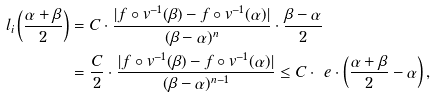<formula> <loc_0><loc_0><loc_500><loc_500>l _ { i } \left ( \frac { \alpha + \beta } { 2 } \right ) & = C \cdot \frac { | f \circ v ^ { - 1 } ( \beta ) - f \circ v ^ { - 1 } ( \alpha ) | } { ( \beta - \alpha ) ^ { n } } \cdot \frac { \beta - \alpha } { 2 } \\ & = \frac { C } { 2 } \cdot \frac { | f \circ v ^ { - 1 } ( \beta ) - f \circ v ^ { - 1 } ( \alpha ) | } { ( \beta - \alpha ) ^ { n - 1 } } \leq C \cdot \ e \cdot \left ( \frac { \alpha + \beta } { 2 } - \alpha \right ) ,</formula> 